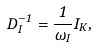Convert formula to latex. <formula><loc_0><loc_0><loc_500><loc_500>{ D } _ { I } ^ { - 1 } = \frac { 1 } { \omega _ { I } } { I } _ { K } ,</formula> 